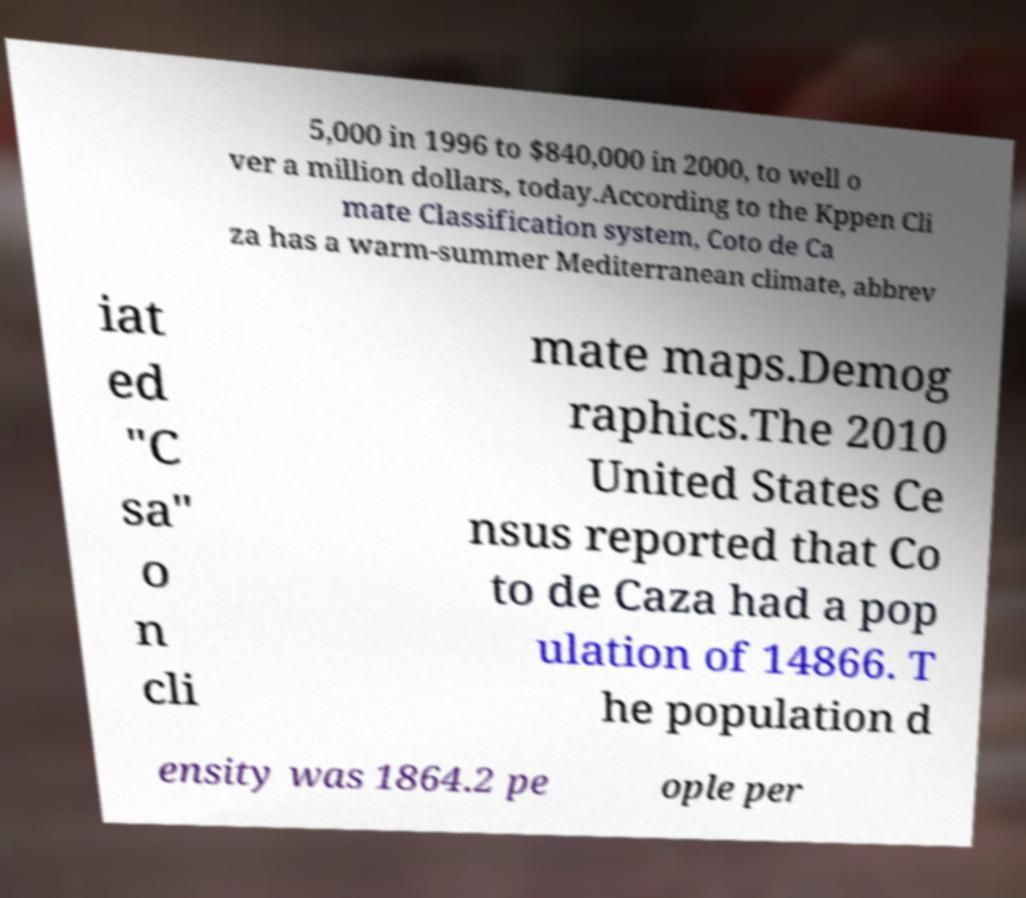Can you accurately transcribe the text from the provided image for me? 5,000 in 1996 to $840,000 in 2000, to well o ver a million dollars, today.According to the Kppen Cli mate Classification system, Coto de Ca za has a warm-summer Mediterranean climate, abbrev iat ed "C sa" o n cli mate maps.Demog raphics.The 2010 United States Ce nsus reported that Co to de Caza had a pop ulation of 14866. T he population d ensity was 1864.2 pe ople per 